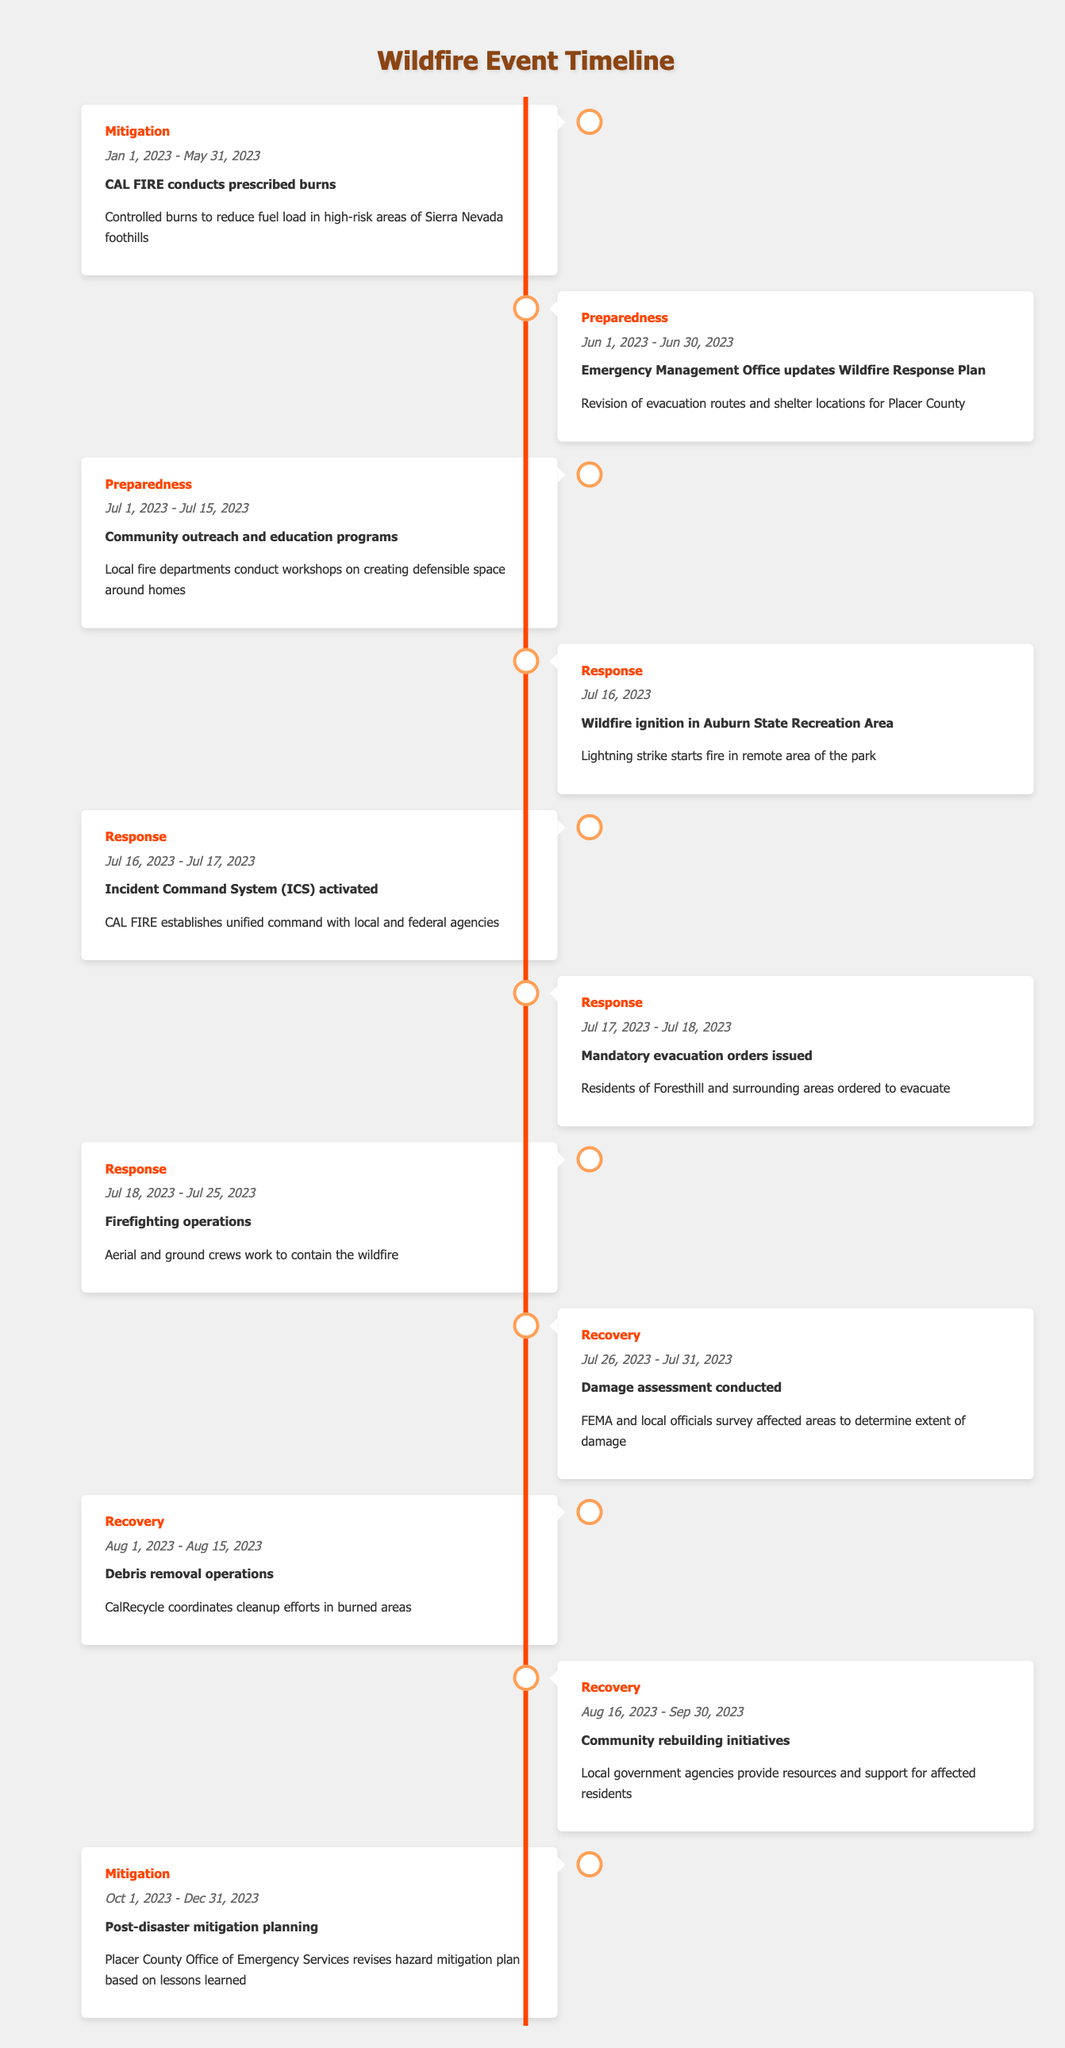What phase did CAL FIRE conduct prescribed burns? The event "CAL FIRE conducts prescribed burns" appears under the "Mitigation" phase in the timeline.
Answer: Mitigation What is the duration of the firefighting operations? The firefighting operations started on July 18, 2023, and ended on July 25, 2023, which is a total of 8 days.
Answer: 8 days Did mandatory evacuation orders get issued for the residents of Foresthill? According to the timeline, mandatory evacuation orders were issued specifically for residents of Foresthill and surrounding areas, validating the fact.
Answer: Yes What events occurred in July 2023? Reviewing the timeline, the events in July 2023 include mandatory evacuation orders, firefighting operations, and the wildfire ignition, with dates from July 16 to July 25 for the first two events, and ignition on July 16.
Answer: Wildfire ignition, mandatory evacuation orders, firefighting operations What was the end date for community rebuilding initiatives? The community rebuilding initiatives ended on September 30, 2023, as stated in the timeline.
Answer: September 30, 2023 What is the total number of days for the Recovery phase? The Recovery phase consists of three events: damage assessment (July 26 - July 31) for 6 days, debris removal (August 1 - August 15) for 15 days, and community rebuilding initiatives (August 16 - September 30) for 45 days. Adding these gives a total of 6 + 15 + 45 = 66 days.
Answer: 66 days Were there any community outreach programs held before the wildfire event? The timeline lists a community outreach and education program that took place from July 1 to July 15, which occurred before the wildfire event that started on July 16.
Answer: Yes What lesson can be inferred about post-disaster planning? The timeline shows that post-disaster mitigation planning started on October 1, 2023, which indicates that learning from past events is essential for future improvements in hazard mitigation plans.
Answer: Planning based on lessons learned is crucial 